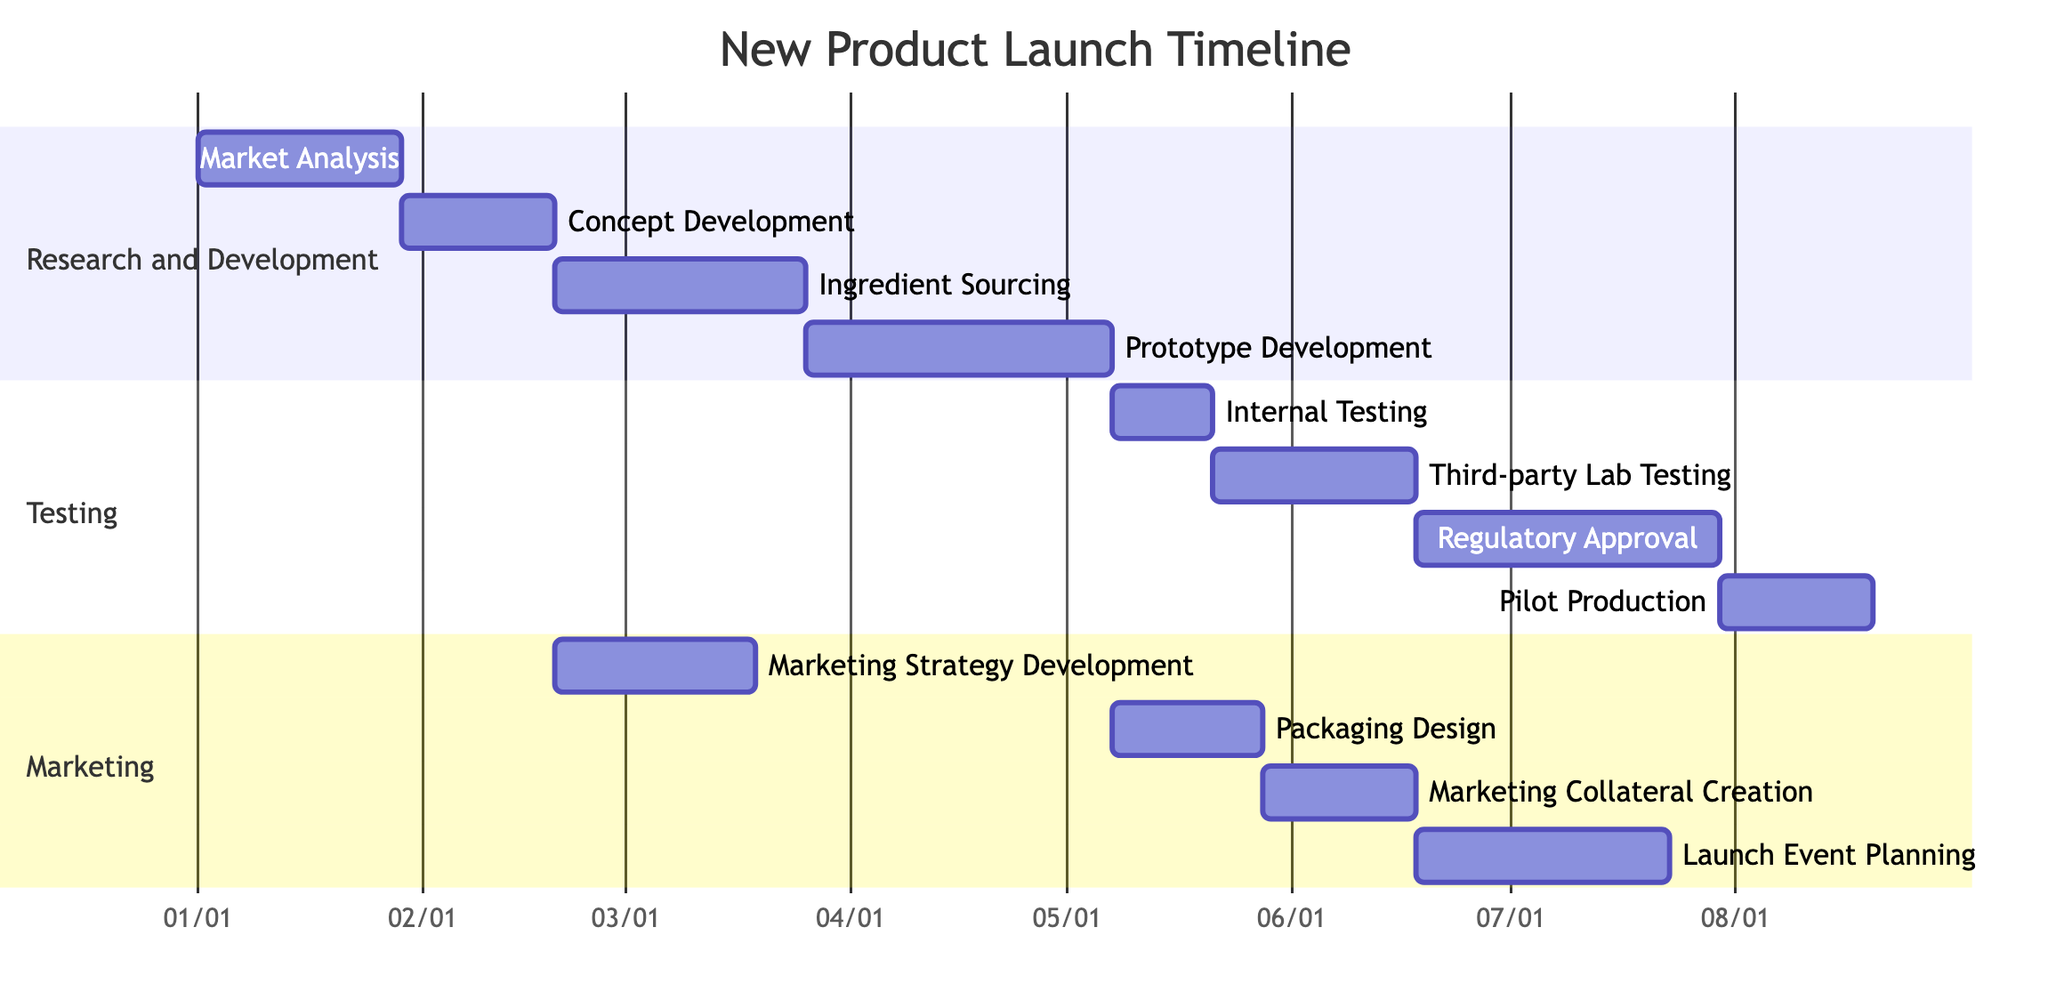What is the duration of the Concept Development task? The diagram indicates that the duration of the Concept Development task is 3 weeks, which is explicitly stated next to the task in the Gantt Chart
Answer: 3 weeks How many tasks are in the Testing phase? By examining the Testing section of the chart, I can count four tasks: Internal Testing, Third-party Lab Testing, Regulatory Approval, and Pilot Production
Answer: 4 Which task depends on Prototype Development? In the Testing phase, Internal Testing directly follows and is dependent on Prototype Development, as shown by the dependency relationship
Answer: Internal Testing What is the total duration of the Marketing phase? The Marketing phase has four tasks: Marketing Strategy Development (4 weeks), Packaging Design (3 weeks), Marketing Collateral Creation (3 weeks), and Launch Event Planning (5 weeks). Summing them gives a total of 15 weeks
Answer: 15 weeks What task follows Regulatory Approval? Pilot Production is the task that comes directly after Regulatory Approval in the sequence of the Gantt Chart
Answer: Pilot Production Which two tasks are dependent on the Concept Development task? Both the Marketing Strategy Development and Ingredient Sourcing tasks depend on the completion of the Concept Development task
Answer: Marketing Strategy Development, Ingredient Sourcing How many weeks do the Profile Development and Internal Testing tasks take together? Adding their durations gives: Prototype Development takes 6 weeks and Internal Testing takes 2 weeks, resulting in a combined duration of 8 weeks
Answer: 8 weeks What is the starting date for the Ingredient Sourcing task? The Ingredient Sourcing task starts immediately after the Concept Development task, which ends at 10 weeks from the initial start date (4 weeks for Market Analysis plus 3 weeks for Concept Development plus 5 weeks for Ingredient Sourcing), placing it at approximately 2023-03-01
Answer: 2023-02-27 Which phase does the task Packaging Design belong to? By examining the sections in the Gantt Chart, Packaging Design clearly falls under the Marketing phase
Answer: Marketing 